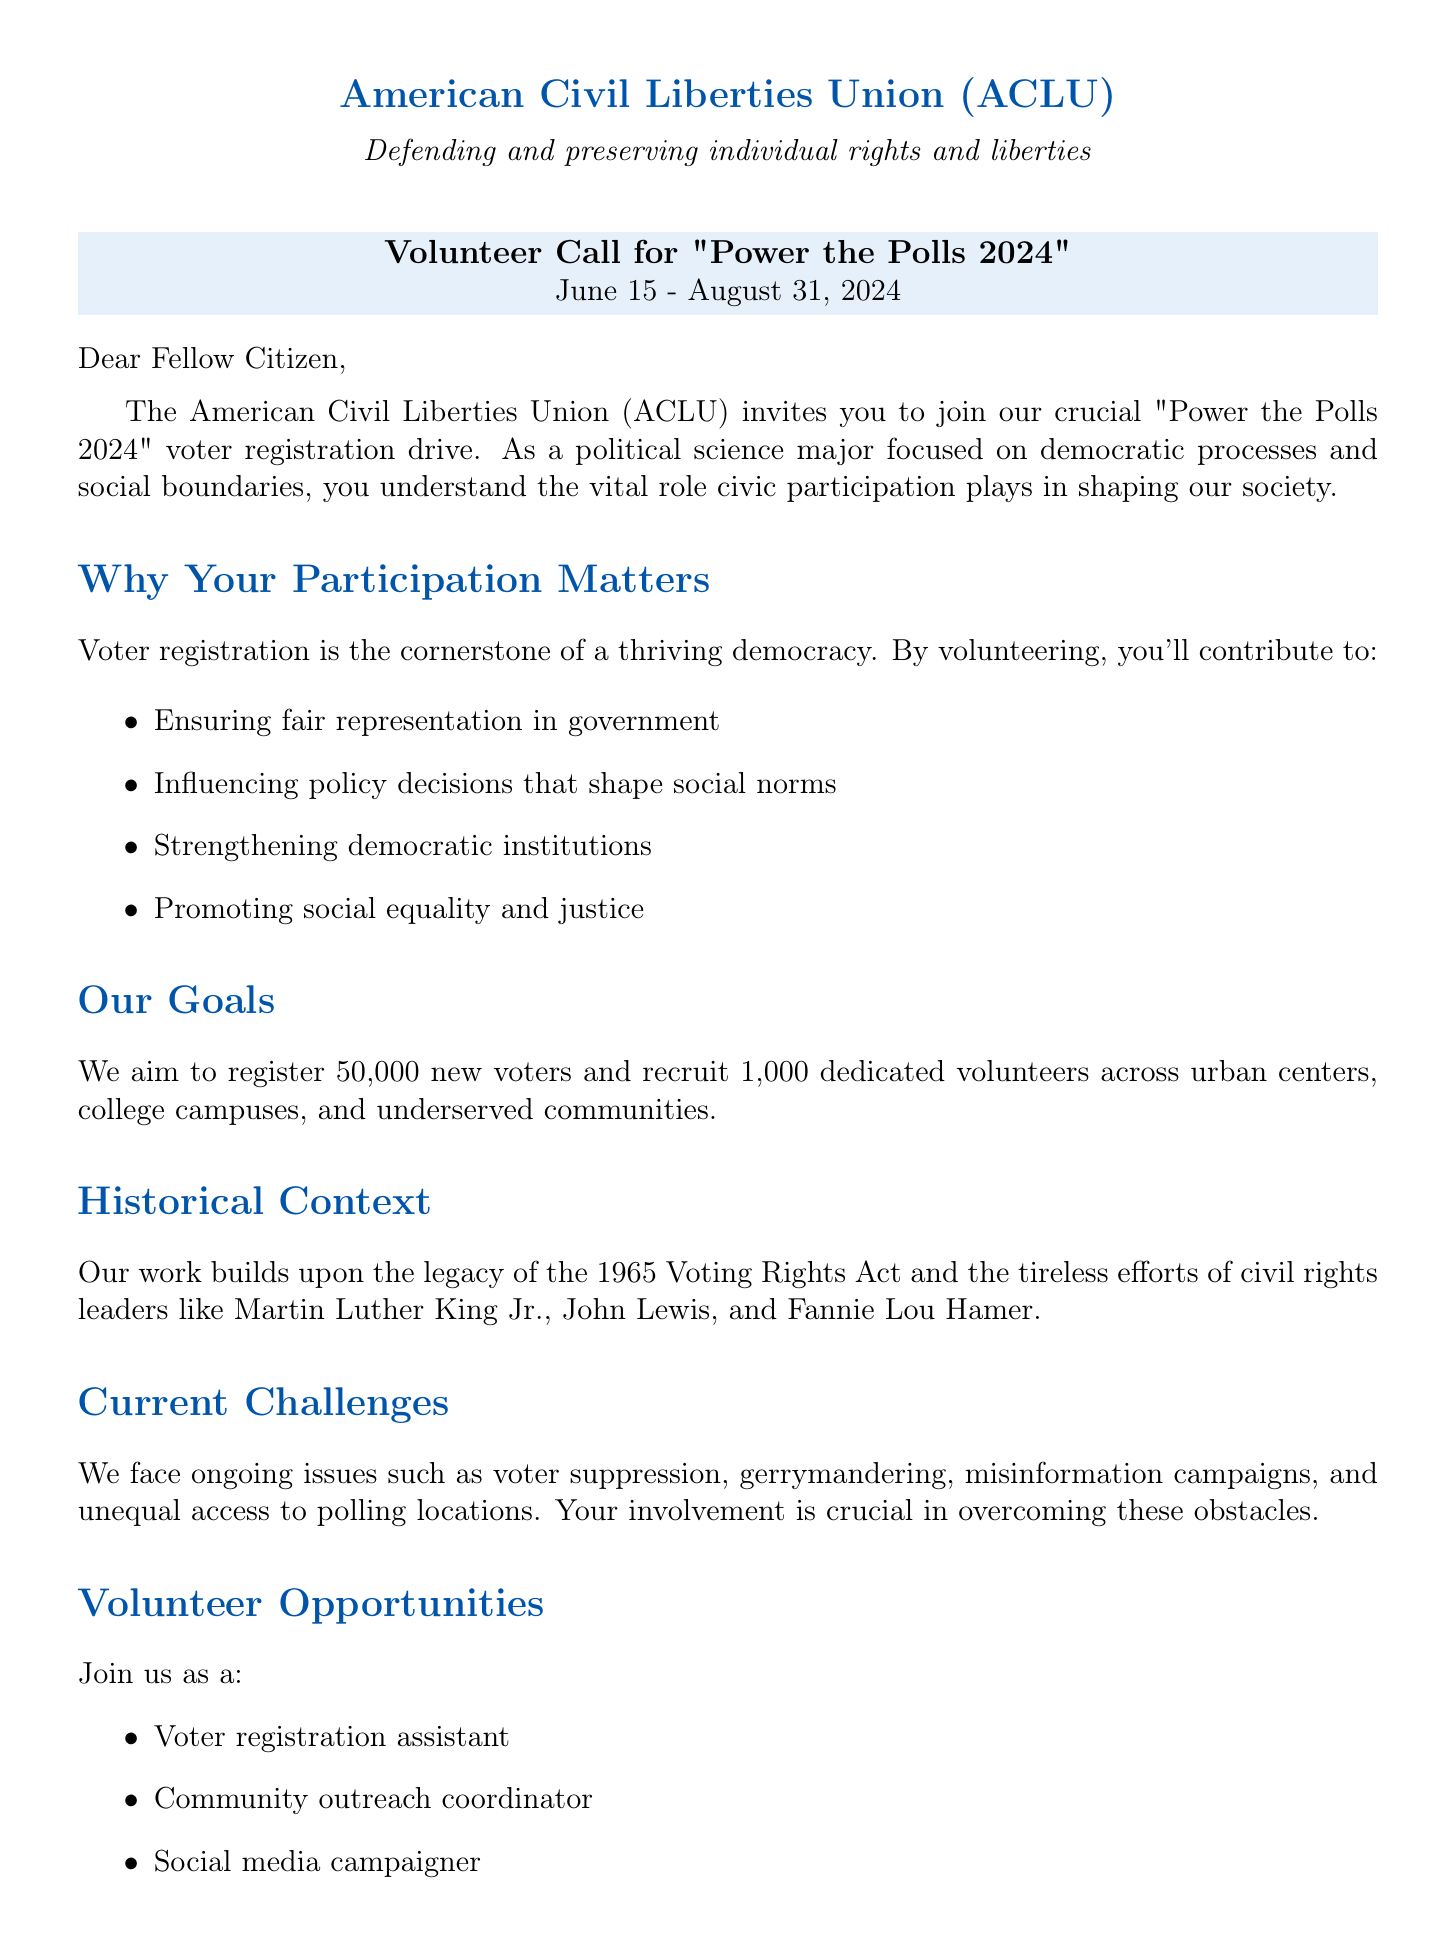what is the name of the voter registration drive? The name of the voter registration drive is stated in the document as "Power the Polls 2024".
Answer: Power the Polls 2024 when does the voter registration drive take place? The document specifies the date range for the voter registration drive as June 15 - August 31, 2024.
Answer: June 15 - August 31, 2024 how many new voters does the ACLU aim to register? The document outlines that the goal is to register 50,000 new voters.
Answer: 50000 who is the contact person for volunteering? The document lists Sarah Johnson as the contact person for volunteering.
Answer: Sarah Johnson what are two challenges faced in the current voting landscape? The document mentions challenges such as voter suppression tactics and gerrymandering.
Answer: Voter suppression and gerrymandering how many volunteers does the ACLU seek to recruit? The document indicates that the organization aims to recruit 1,000 dedicated volunteers.
Answer: 1000 what organization is hosting the voter registration drive? The document states that the organization hosting the drive is the American Civil Liberties Union (ACLU).
Answer: American Civil Liberties Union (ACLU) what impact will this drive have on social norms? The document specifies that it will contribute to increasing diversity in political representation and shifting public discourse on social issues.
Answer: Increasing diversity in political representation what type of document is this? This letter is an invitation for volunteers to participate in a voter registration drive.
Answer: Invitation letter 